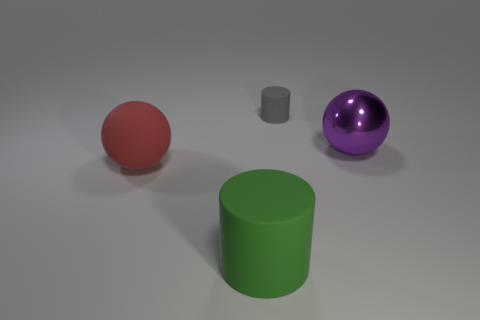Add 4 tiny green metal cubes. How many objects exist? 8 Subtract 0 yellow cylinders. How many objects are left? 4 Subtract all green rubber objects. Subtract all matte objects. How many objects are left? 0 Add 2 spheres. How many spheres are left? 4 Add 1 small gray metal blocks. How many small gray metal blocks exist? 1 